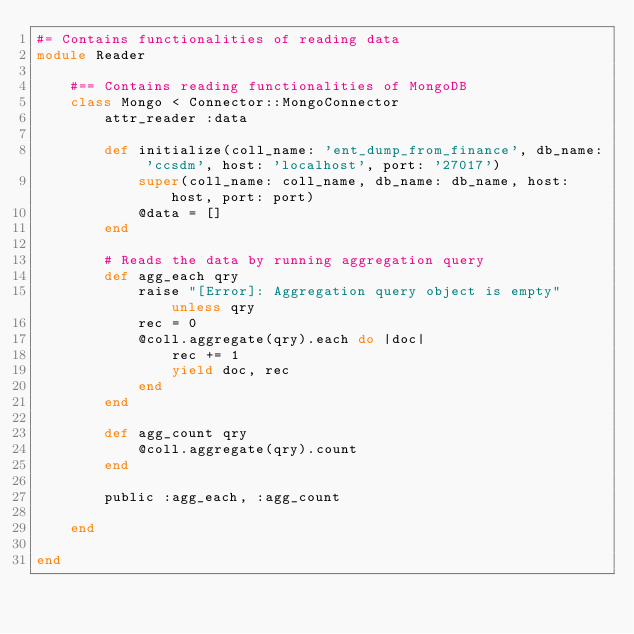<code> <loc_0><loc_0><loc_500><loc_500><_Ruby_>#= Contains functionalities of reading data
module Reader

    #== Contains reading functionalities of MongoDB
    class Mongo < Connector::MongoConnector
        attr_reader :data

        def initialize(coll_name: 'ent_dump_from_finance', db_name: 'ccsdm', host: 'localhost', port: '27017')
            super(coll_name: coll_name, db_name: db_name, host: host, port: port)
            @data = []
        end

        # Reads the data by running aggregation query
        def agg_each qry
            raise "[Error]: Aggregation query object is empty" unless qry
            rec = 0
            @coll.aggregate(qry).each do |doc|
                rec += 1
                yield doc, rec
            end
        end

        def agg_count qry
            @coll.aggregate(qry).count
        end

        public :agg_each, :agg_count

    end

end
</code> 